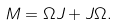Convert formula to latex. <formula><loc_0><loc_0><loc_500><loc_500>M = \Omega J + J \Omega .</formula> 